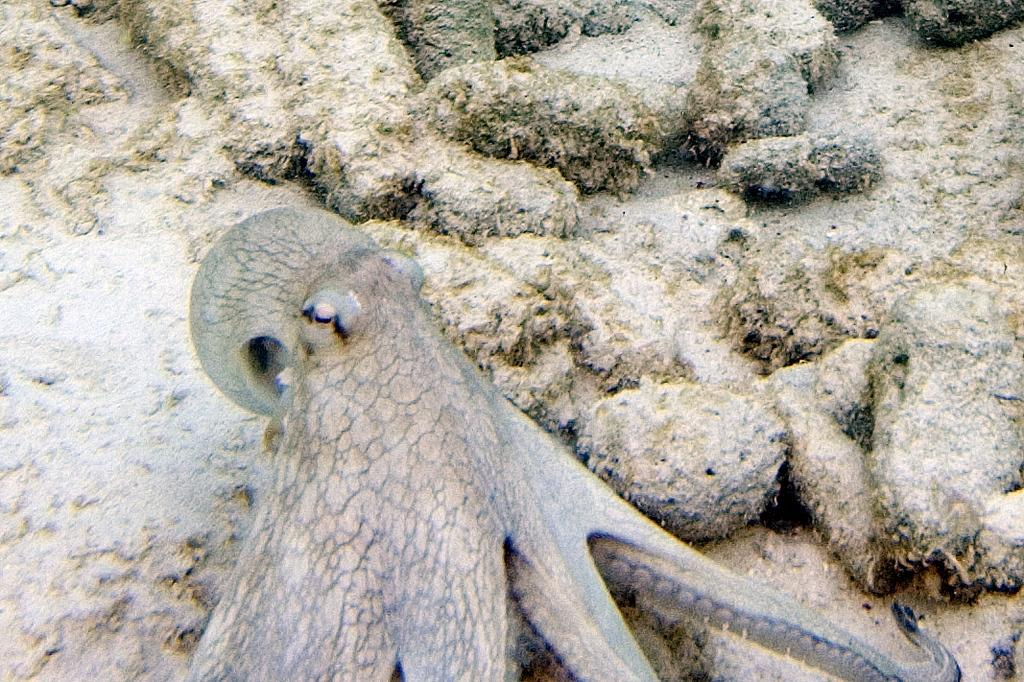Where was the image taken? The image is taken inside water. What can be seen in the image? There is an octopus in the image. Where is the octopus located in the image? The octopus is at the bottom of the image. What type of terrain is visible in the image? There is sand and stones in the image. What type of jam can be seen on the ant in the image? There are no ants or jam present in the image. 